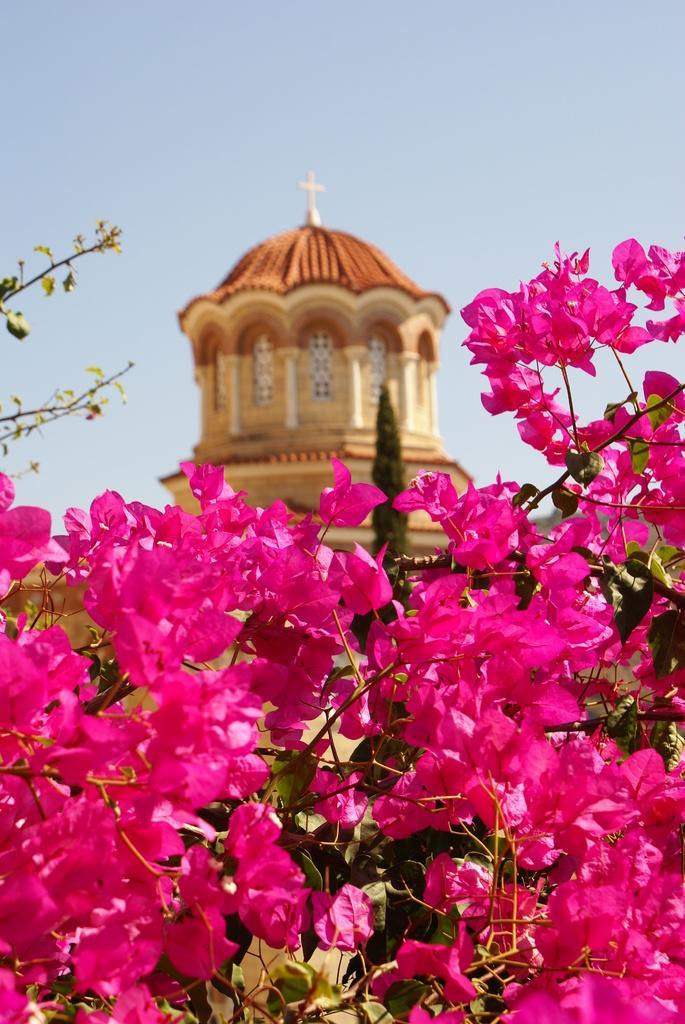Please provide a concise description of this image. This picture is clicked outside. In the foreground we can see the flowers and the leaves. In the background we can see the sky, tree and a tower like object. 